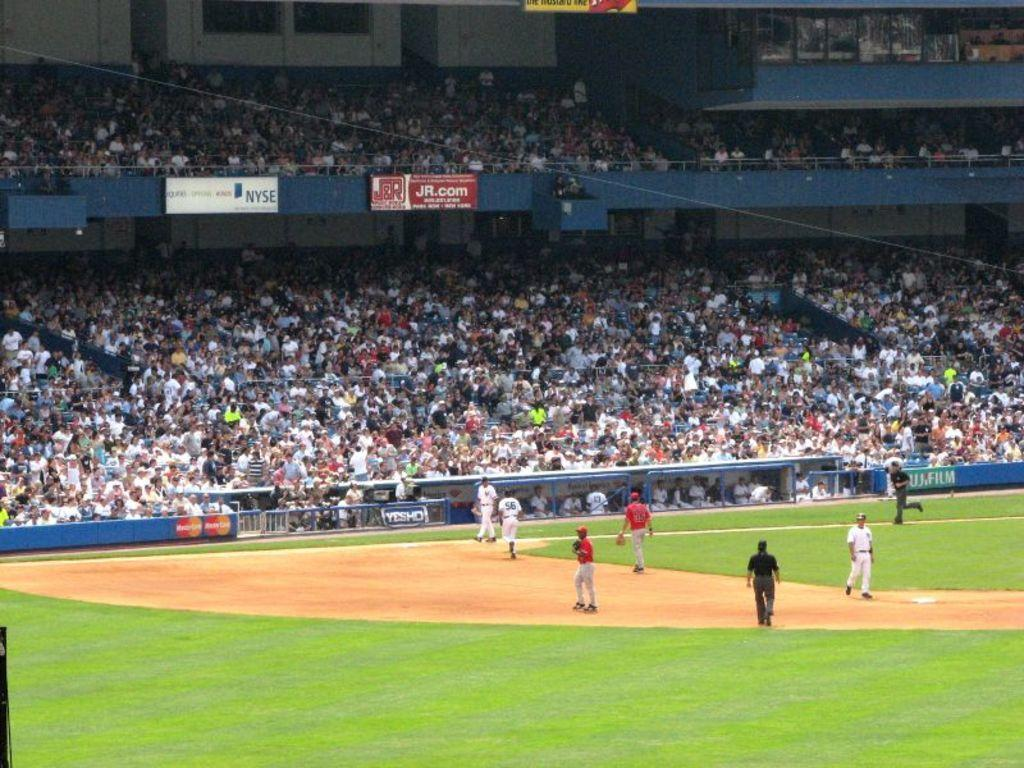What is happening at the bottom of the image? There are persons on the ground at the bottom of the image. What can be seen in the background of the image? There is a crowd, chairs, stairs, and fencing in the background of the image. Can you describe the arrangement of the chairs in the background? Unfortunately, the provided facts do not give enough information to describe the arrangement of the chairs. What might the stairs be used for in the image? The stairs in the background of the image might be used for accessing a higher level or as a decorative element. What type of nerve is responsible for the growth of the committee in the image? There is no mention of a nerve, growth, or committee in the image. The image features persons on the ground and various elements in the background, such as a crowd, chairs, stairs, and fencing. 